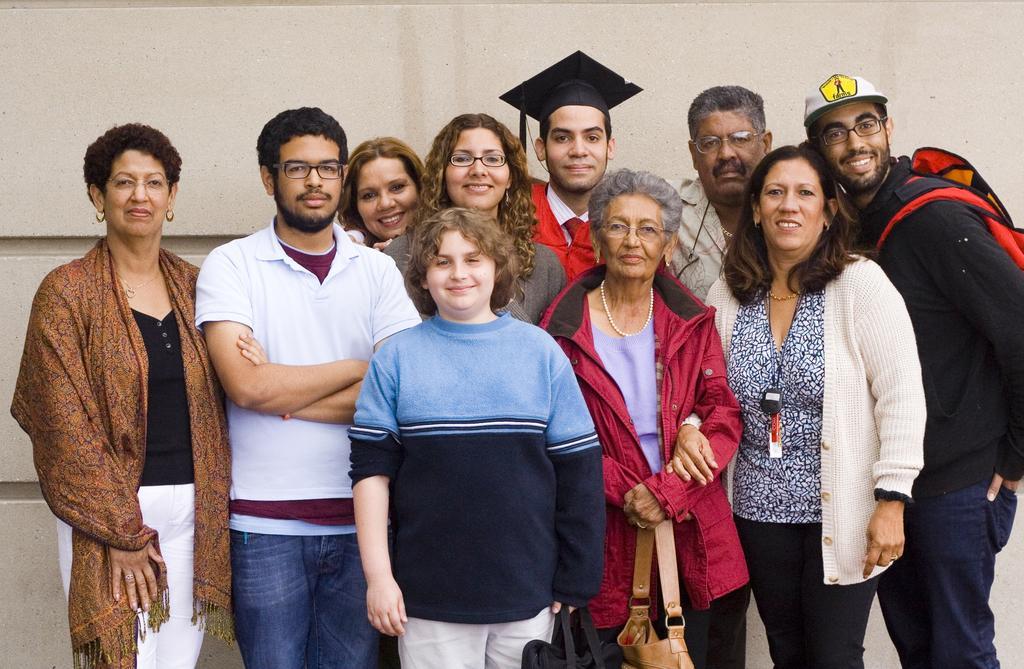How would you summarize this image in a sentence or two? In the foreground of this image, there are few people standing and posing to a camera. In the background, there is a wall. 